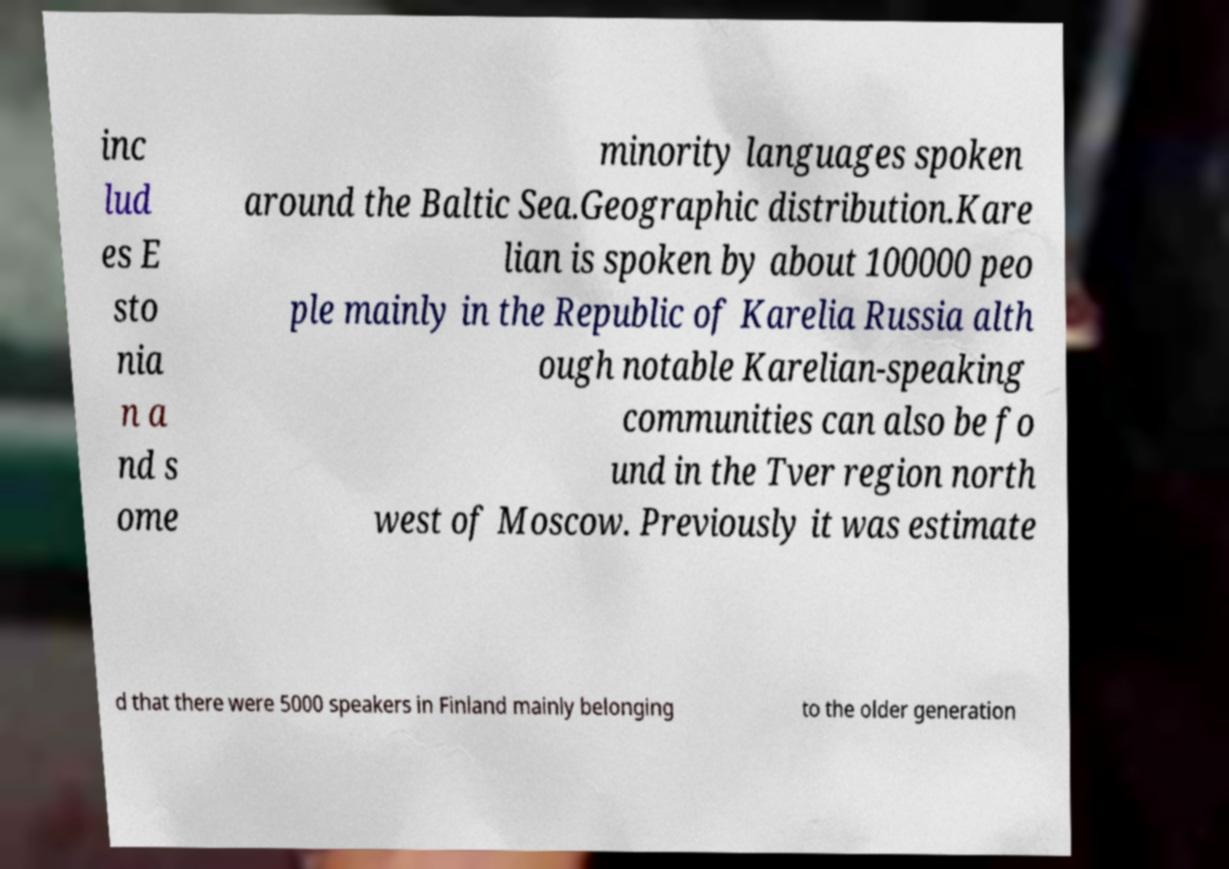Can you accurately transcribe the text from the provided image for me? inc lud es E sto nia n a nd s ome minority languages spoken around the Baltic Sea.Geographic distribution.Kare lian is spoken by about 100000 peo ple mainly in the Republic of Karelia Russia alth ough notable Karelian-speaking communities can also be fo und in the Tver region north west of Moscow. Previously it was estimate d that there were 5000 speakers in Finland mainly belonging to the older generation 